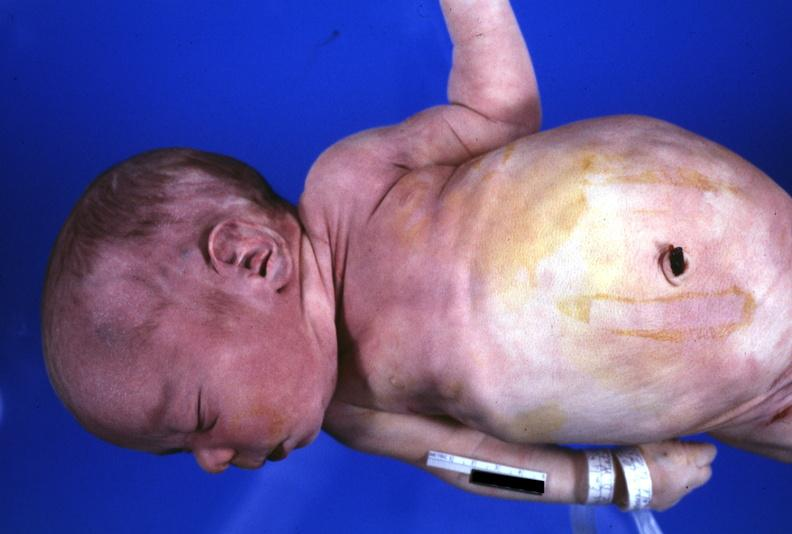what does this image show?
Answer the question using a single word or phrase. View of low set ears 